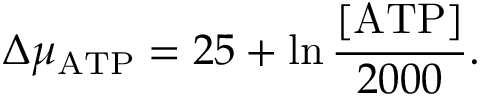Convert formula to latex. <formula><loc_0><loc_0><loc_500><loc_500>\Delta \mu _ { A T P } = 2 5 + \ln { \frac { [ A T P ] } { 2 0 0 0 } } .</formula> 